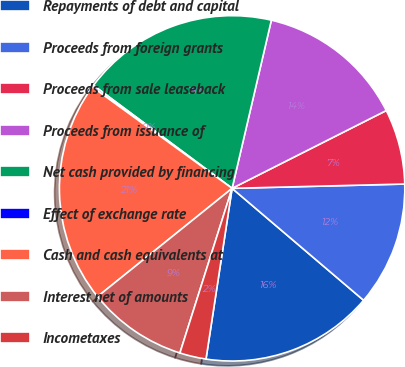Convert chart to OTSL. <chart><loc_0><loc_0><loc_500><loc_500><pie_chart><fcel>Repayments of debt and capital<fcel>Proceeds from foreign grants<fcel>Proceeds from sale leaseback<fcel>Proceeds from issuance of<fcel>Net cash provided by financing<fcel>Effect of exchange rate<fcel>Cash and cash equivalents at<fcel>Interest net of amounts<fcel>Incometaxes<nl><fcel>16.19%<fcel>11.62%<fcel>7.04%<fcel>13.91%<fcel>18.48%<fcel>0.18%<fcel>20.77%<fcel>9.33%<fcel>2.47%<nl></chart> 